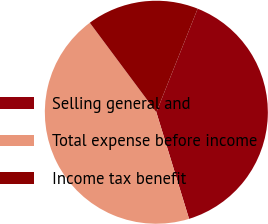<chart> <loc_0><loc_0><loc_500><loc_500><pie_chart><fcel>Selling general and<fcel>Total expense before income<fcel>Income tax benefit<nl><fcel>39.22%<fcel>44.56%<fcel>16.22%<nl></chart> 